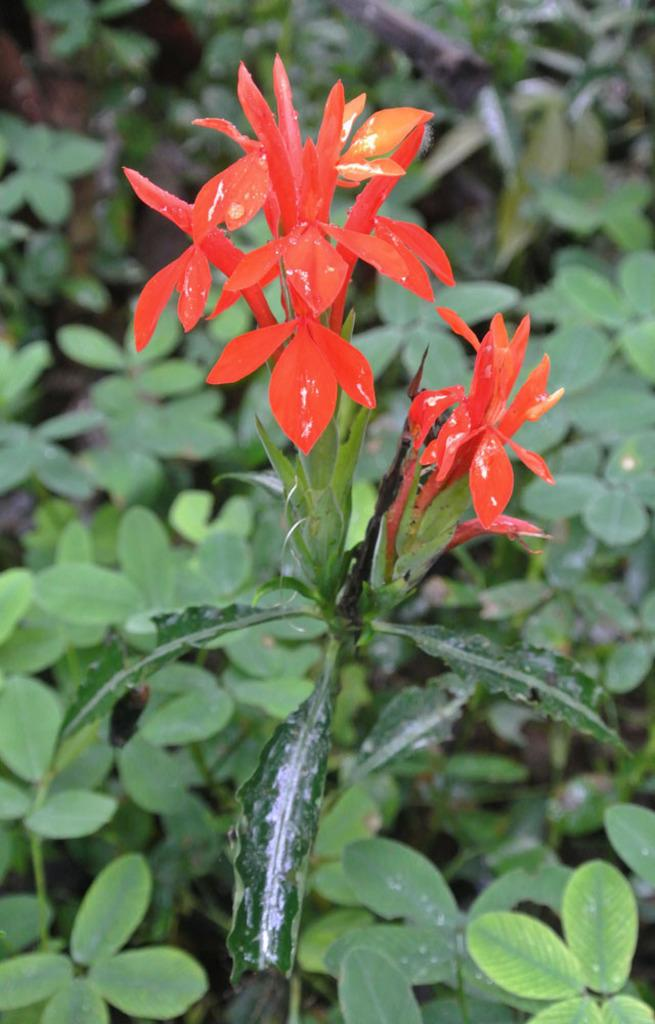What type of living organisms can be seen in the image? Plants can be seen in the image. What is the color of the plants in the image? The plants are green in color. Can you describe any specific features of the plants? Yes, there is a flower can be seen on one of the plants. What is the color of the flower? The flower is reddish orange in color. What type of bridge can be seen in the image? There is no bridge present in the image; it features plants and a flower. What substance is being used to create the flower in the image? The image is a photograph or illustration, and no actual substance is being used to create the flower. 